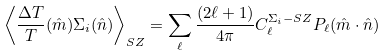<formula> <loc_0><loc_0><loc_500><loc_500>\left \langle \frac { \Delta T } { T } ( { \hat { m } } ) \Sigma _ { i } ( { \hat { n } } ) \right \rangle _ { S Z } = \sum _ { \ell } \frac { ( 2 \ell + 1 ) } { 4 \pi } C _ { \ell } ^ { \Sigma _ { i } - S Z } P _ { \ell } ( { \hat { m } } \cdot { \hat { n } } )</formula> 